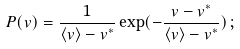Convert formula to latex. <formula><loc_0><loc_0><loc_500><loc_500>P ( v ) = \frac { 1 } { \left < v \right > - v ^ { * } } \exp ( - \frac { v - v ^ { * } } { \left < v \right > - v ^ { * } } ) \, ;</formula> 